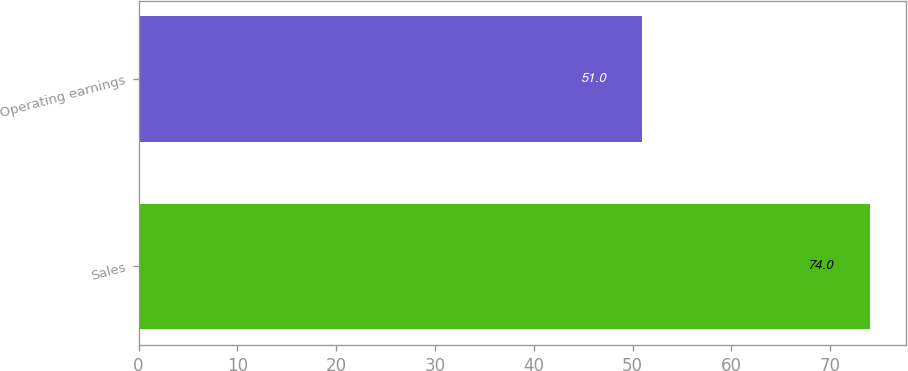Convert chart to OTSL. <chart><loc_0><loc_0><loc_500><loc_500><bar_chart><fcel>Sales<fcel>Operating earnings<nl><fcel>74<fcel>51<nl></chart> 